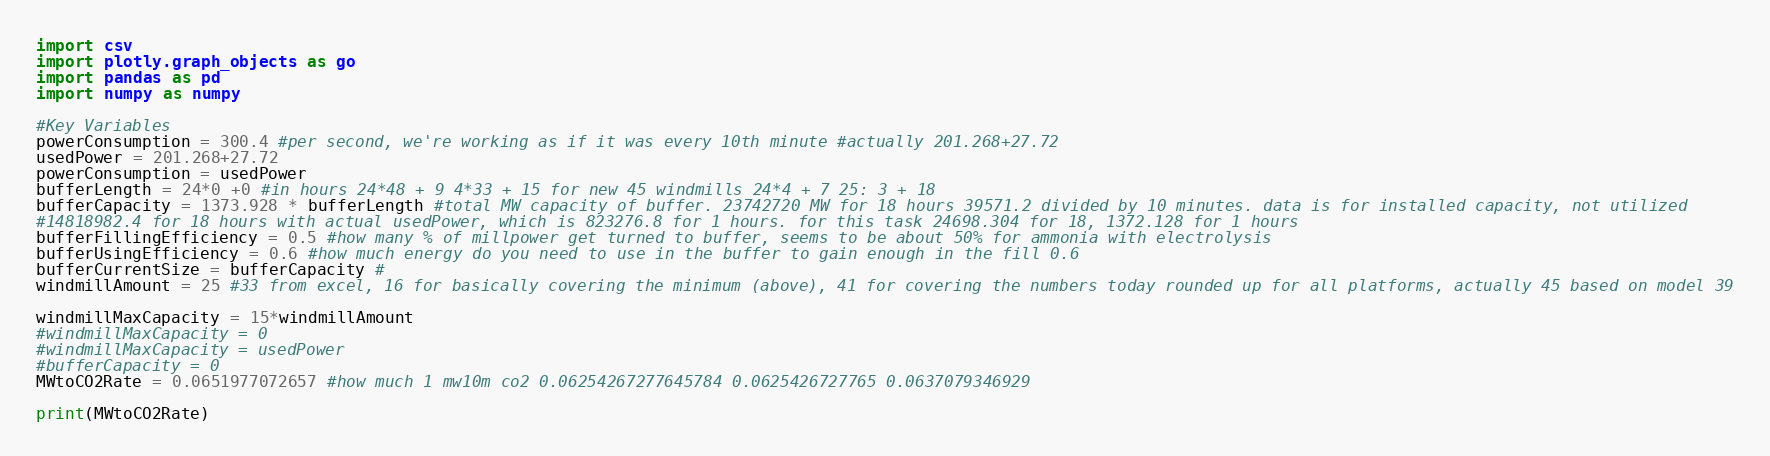Convert code to text. <code><loc_0><loc_0><loc_500><loc_500><_Python_>import csv
import plotly.graph_objects as go
import pandas as pd
import numpy as numpy

#Key Variables
powerConsumption = 300.4 #per second, we're working as if it was every 10th minute #actually 201.268+27.72
usedPower = 201.268+27.72
powerConsumption = usedPower
bufferLength = 24*0 +0 #in hours 24*48 + 9 4*33 + 15 for new 45 windmills 24*4 + 7 25: 3 + 18
bufferCapacity = 1373.928 * bufferLength #total MW capacity of buffer. 23742720 MW for 18 hours 39571.2 divided by 10 minutes. data is for installed capacity, not utilized
#14818982.4 for 18 hours with actual usedPower, which is 823276.8 for 1 hours. for this task 24698.304 for 18, 1372.128 for 1 hours
bufferFillingEfficiency = 0.5 #how many % of millpower get turned to buffer, seems to be about 50% for ammonia with electrolysis
bufferUsingEfficiency = 0.6 #how much energy do you need to use in the buffer to gain enough in the fill 0.6
bufferCurrentSize = bufferCapacity #
windmillAmount = 25 #33 from excel, 16 for basically covering the minimum (above), 41 for covering the numbers today rounded up for all platforms, actually 45 based on model 39

windmillMaxCapacity = 15*windmillAmount
#windmillMaxCapacity = 0
#windmillMaxCapacity = usedPower
#bufferCapacity = 0
MWtoCO2Rate = 0.0651977072657 #how much 1 mw10m co2 0.06254267277645784 0.0625426727765 0.0637079346929

print(MWtoCO2Rate)</code> 